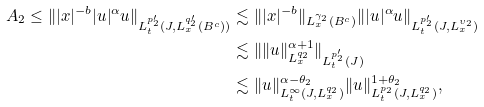Convert formula to latex. <formula><loc_0><loc_0><loc_500><loc_500>A _ { 2 } \leq \| | x | ^ { - b } | u | ^ { \alpha } u \| _ { L ^ { p _ { 2 } ^ { \prime } } _ { t } ( J , L ^ { q _ { 2 } ^ { \prime } } _ { x } ( B ^ { c } ) ) } & \lesssim \| | x | ^ { - b } \| _ { L ^ { \gamma _ { 2 } } _ { x } ( B ^ { c } ) } \| | u | ^ { \alpha } u \| _ { L ^ { p _ { 2 } ^ { \prime } } _ { t } ( J , L ^ { \upsilon _ { 2 } } _ { x } ) } \\ & \lesssim \| \| u \| ^ { \alpha + 1 } _ { L ^ { q _ { 2 } } _ { x } } \| _ { L ^ { p _ { 2 } ^ { \prime } } _ { t } ( J ) } \\ & \lesssim \| u \| ^ { \alpha - \theta _ { 2 } } _ { L ^ { \infty } _ { t } ( J , L ^ { q _ { 2 } } _ { x } ) } \| u \| ^ { 1 + \theta _ { 2 } } _ { L ^ { p _ { 2 } } _ { t } ( J , L ^ { q _ { 2 } } _ { x } ) } ,</formula> 